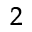<formula> <loc_0><loc_0><loc_500><loc_500>^ { \, 2 }</formula> 